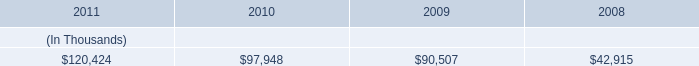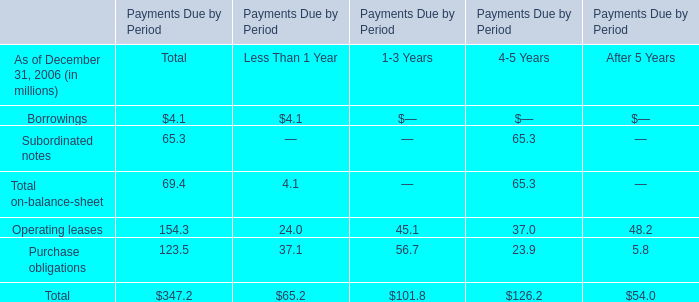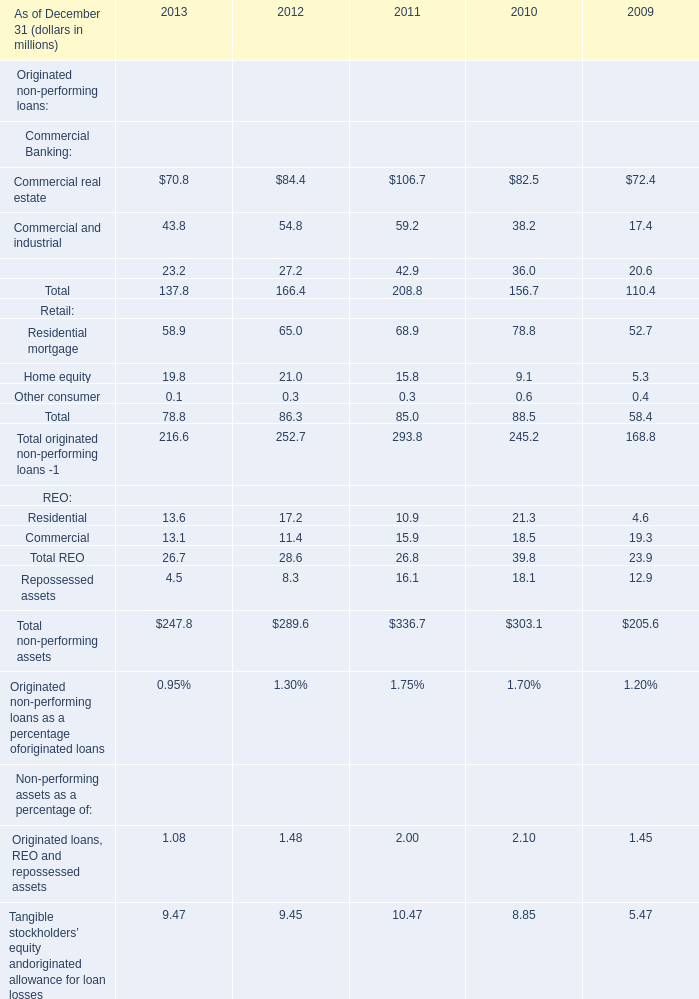What was the total amount of Originated non-performing loans excluding those Originated non-performing loans greater than 30 in 2012 ? (in million) 
Computations: ((84.4 + 54.8) + 65)
Answer: 204.2. 